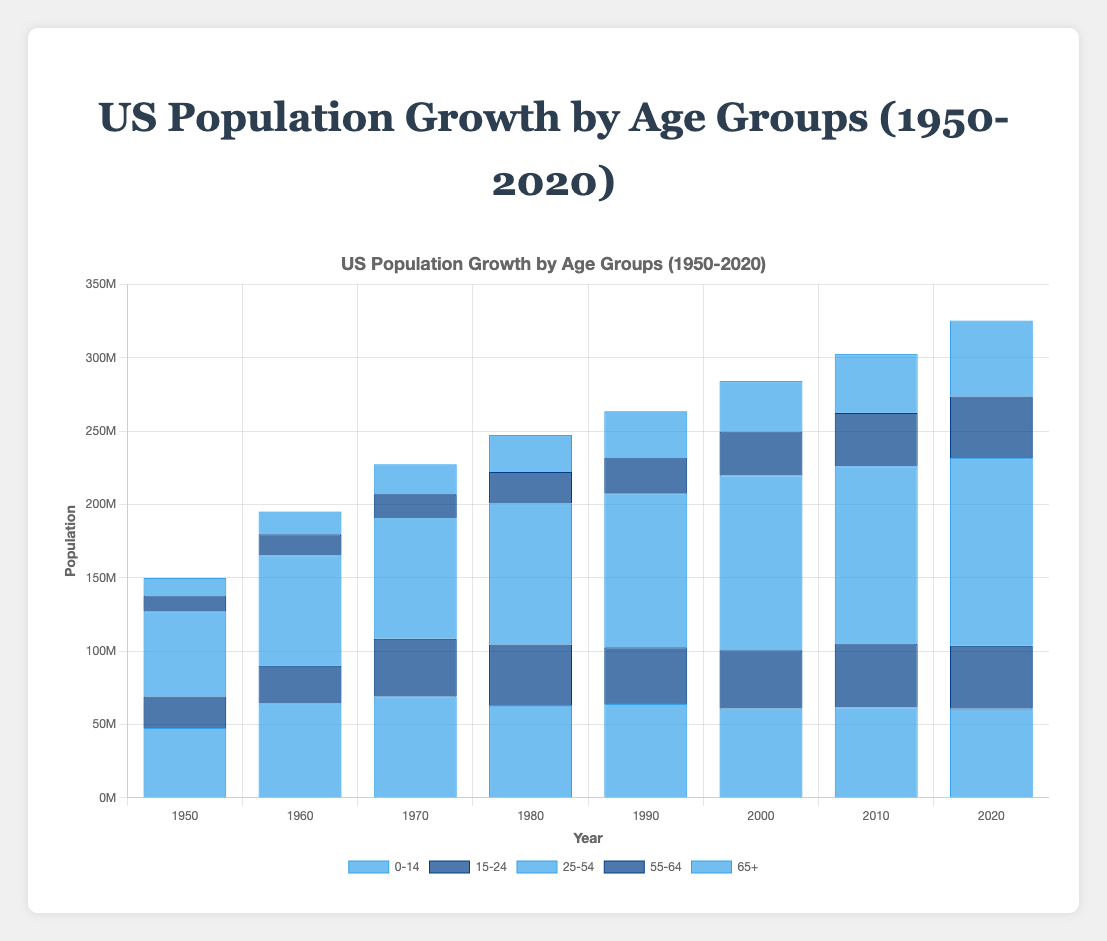What's the general trend in the population of the 65+ age group from 1950 to 2020? Look at the heights of the bars for the 65+ age group in each year. The bar heights show that the population for this age group consistently increased from 12 million in 1950 to 51.8 million in 2020.
Answer: Increasing trend Which age group had the highest population in 2020? Compare the heights of the bars for each age group in 2020. The bar for the 25-54 age group is the tallest, indicating that it had the highest population at 128 million.
Answer: 25-54 How did the population of the 0-14 age group change between 1950 and 2020? Observe the heights of the bars for the 0-14 age group in both 1950 and 2020. The population increased from 47.6 million in 1950 to 60.8 million in 2020.
Answer: Increased What is the difference in population between the 15-24 age group in 2010 and 2020? Look at the heights of the bars for the 15-24 age group in 2010 and 2020. Subtract the value in 2020 (42.9 million) from the value in 2010 (43.5 million). 43.5 million - 42.9 million = 0.6 million.
Answer: 0.6 million Which age group showed the highest relative growth from 1950 to 2020? Calculate the relative growth for each age group by dividing the 2020 population by the 1950 population and examine which one has the highest value: 
- 0-14: 60.8M / 47.6M ≈ 1.28
- 15-24: 42.9M / 21.5M ≈ 2.00
- 25-54: 128M / 57.9M ≈ 2.21
- 55-64: 42M / 10.9M ≈ 3.85
- 65+: 51.8M / 12M ≈ 4.32
The 65+ group has the highest relative growth.
Answer: 65+ What is the average population across all age groups in 1990? Sum the populations across all age groups in 1990 and divide by the number of groups:
(64M + 38.6M + 105.2M + 24.3M + 31.6M) / 5 = 52.72 million.
Answer: 52.72 million How does the population in the 55-64 age group in 2020 compare to that in 2000? Compare the heights of the bars for the 55-64 age group in 2020 (42 million) and 2000 (29.9 million). The population in 2020 is higher.
Answer: Higher in 2020 Which age groups' populations have decreased at any point between 1950 and 2020? Check each age group's bar heights for any decrease between consecutive decades:
- 0-14: Decreased from 69M in 1970 to 62.7M in 1980.
- 25-54: No decrease.
- 15-24: No decrease.
- 55-64: No decrease.
- 65+: No decrease.
Only the 0-14 age group shows a decrease between 1970 and 1980.
Answer: 0-14 